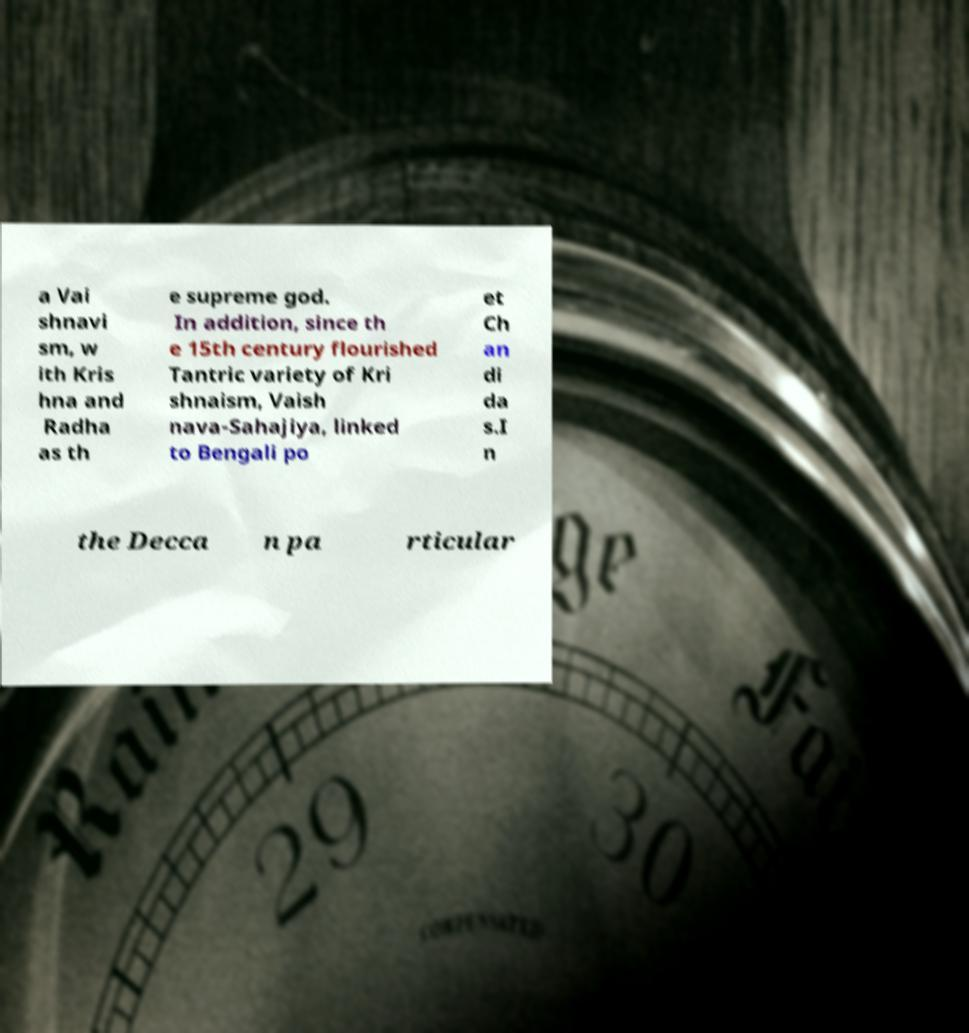For documentation purposes, I need the text within this image transcribed. Could you provide that? a Vai shnavi sm, w ith Kris hna and Radha as th e supreme god. In addition, since th e 15th century flourished Tantric variety of Kri shnaism, Vaish nava-Sahajiya, linked to Bengali po et Ch an di da s.I n the Decca n pa rticular 